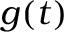<formula> <loc_0><loc_0><loc_500><loc_500>g ( t )</formula> 